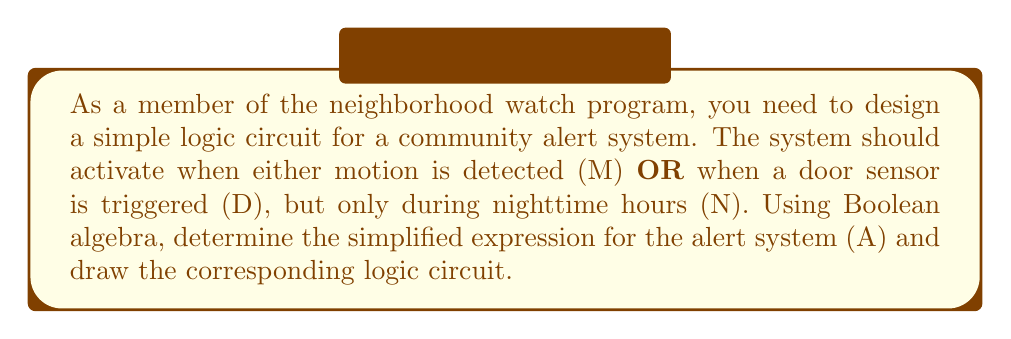Could you help me with this problem? Let's approach this step-by-step:

1) First, we need to express the alert system (A) in terms of our inputs:
   $A = N \cdot (M + D)$

   This means the alert is active (1) when it's nighttime AND either motion is detected OR a door sensor is triggered.

2) We can expand this using the distributive property:
   $A = N \cdot M + N \cdot D$

3) This expression is already in its simplest form (Sum of Products), so we don't need to simplify further.

4) Now, let's design the logic circuit:
   - We need an OR gate for (M + D)
   - We need two AND gates: one for (N · M) and one for (N · D)
   - Finally, we need another OR gate to combine the outputs of the two AND gates

5) Here's the logic circuit diagram:

[asy]
import geometry;

pair A = (0,0), B = (0,50), C = (0,100), D = (100,25), E = (100,75), F = (200,50), G = (300,50);

draw(A--D--B);
draw(B--E--C);
draw(D--F);
draw(E--F);
draw(F--G);

label("M", A, W);
label("D", B, W);
label("N", C, W);
label("OR", D, E);
label("AND", E, N);
label("AND", D, S);
label("OR", F, E);
label("A", G, E);

draw(circle(D,10));
draw(circle(E,10));
draw(circle(F,10));

label("&", D, fontsize(8));
label("&", E, fontsize(8));
label("≥1", F, fontsize(8));
[/asy]

This circuit implements the Boolean expression $A = N \cdot M + N \cdot D$, which will activate the alert system under the required conditions.
Answer: $A = N \cdot M + N \cdot D$ 